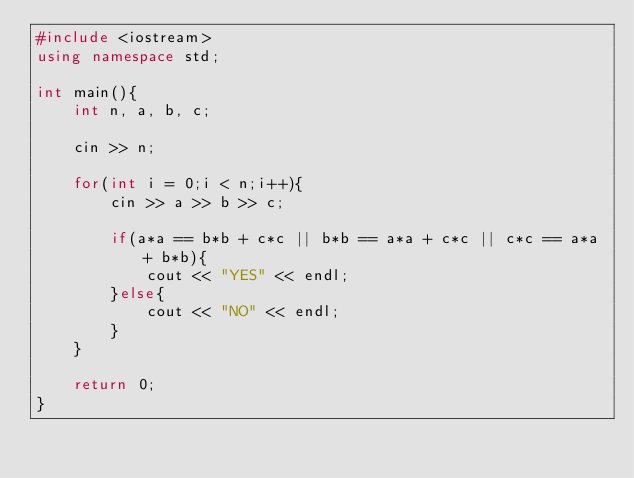Convert code to text. <code><loc_0><loc_0><loc_500><loc_500><_C++_>#include <iostream>
using namespace std;

int main(){
    int n, a, b, c;
    
    cin >> n;
    
    for(int i = 0;i < n;i++){
        cin >> a >> b >> c;
        
        if(a*a == b*b + c*c || b*b == a*a + c*c || c*c == a*a + b*b){
            cout << "YES" << endl;
        }else{
            cout << "NO" << endl;
        }
    }
    
    return 0;
}</code> 